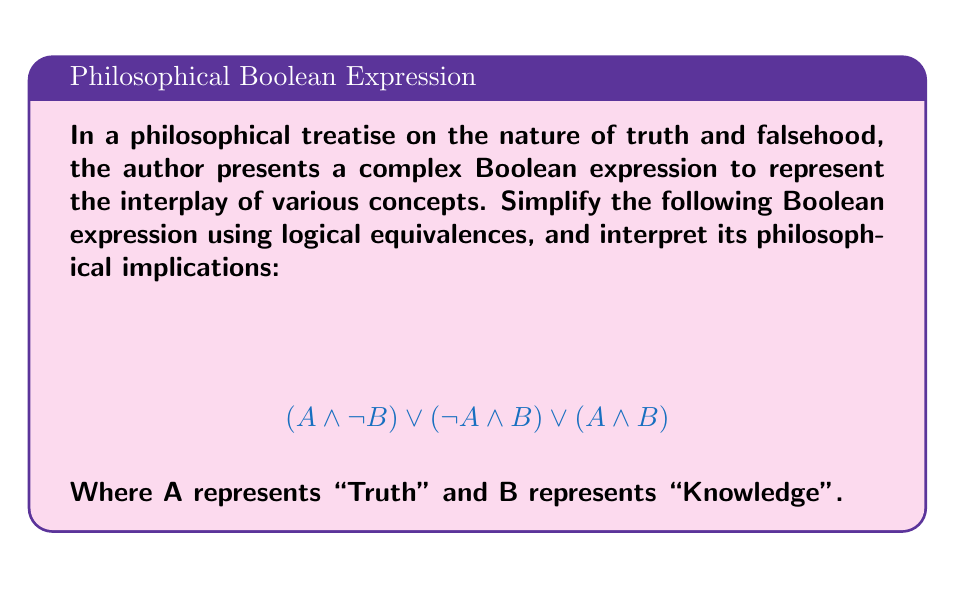What is the answer to this math problem? Let's simplify this expression step by step:

1) First, we can recognize that $(A \land \lnot B) \lor (\lnot A \land B)$ is the exclusive OR (XOR) of A and B. Let's call this X:

   $X = (A \land \lnot B) \lor (\lnot A \land B)$

2) Our expression is now:

   $X \lor (A \land B)$

3) We can expand X:

   $(A \land \lnot B) \lor (\lnot A \land B) \lor (A \land B)$

4) Now, we can use the distributive law to factor out B:

   $(A \land \lnot B) \lor (B \land (\lnot A \lor A))$

5) $(\lnot A \lor A)$ is a tautology (always true), so it simplifies to 1:

   $(A \land \lnot B) \lor (B \land 1)$

6) $(B \land 1)$ simplifies to just B:

   $(A \land \lnot B) \lor B$

7) We can use the distributive law again:

   $A \land \lnot B \lor B$

8) $\lnot B \lor B$ is a tautology, so it simplifies to 1:

   $A \land 1 \lor B$

9) $A \land 1$ simplifies to just A:

   $A \lor B$

Philosophical interpretation: The simplified expression $A \lor B$ suggests that either Truth (A) or Knowledge (B) (or both) is sufficient for the proposition to be true. This could be interpreted as saying that in the realm of philosophy, either the presence of absolute truth or the possession of knowledge (or both) is enough to affirm a philosophical concept.
Answer: $A \lor B$ 